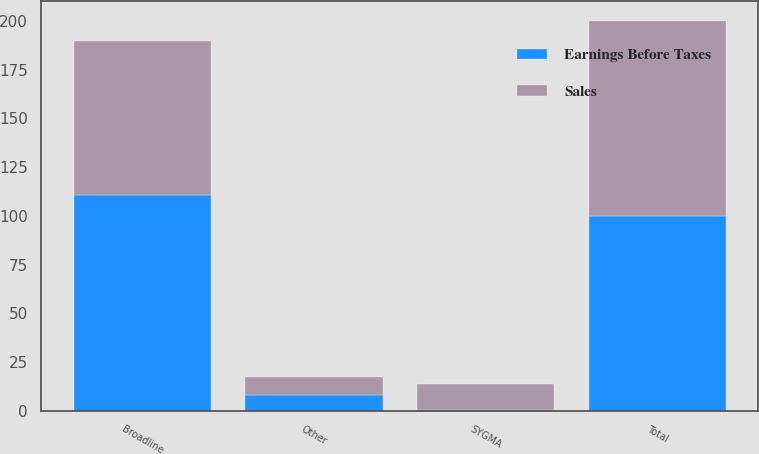<chart> <loc_0><loc_0><loc_500><loc_500><stacked_bar_chart><ecel><fcel>Broadline<fcel>SYGMA<fcel>Other<fcel>Total<nl><fcel>Sales<fcel>78.7<fcel>13.3<fcel>9.2<fcel>100<nl><fcel>Earnings Before Taxes<fcel>110.8<fcel>0.6<fcel>7.9<fcel>100<nl></chart> 